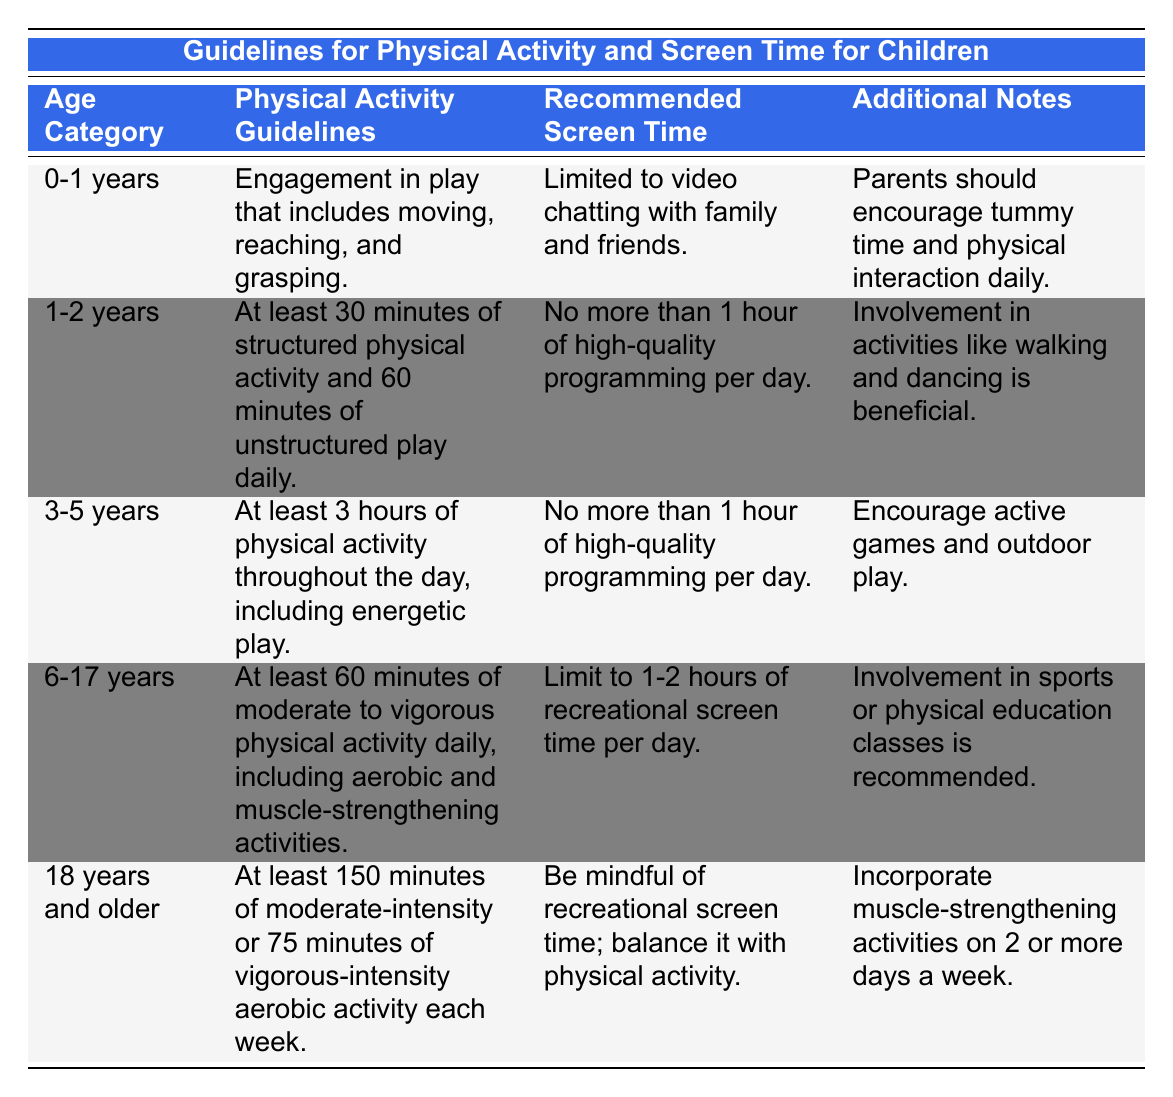What are the physical activity guidelines for 3-5 years age category? According to the table, for the age category 3-5 years, the physical activity guideline is to engage in at least 3 hours of physical activity throughout the day, including energetic play.
Answer: At least 3 hours of physical activity What is the recommended screen time for children aged 1-2 years? The table indicates that for children aged 1-2 years, the recommended screen time is no more than 1 hour of high-quality programming per day.
Answer: No more than 1 hour Is it suggested that children aged 6-17 years participate in sports? The table states that involvement in sports or physical education classes is recommended for children aged 6-17 years, indicating yes to this suggestion.
Answer: Yes How does the screen time recommendation change as children age from 3-5 years to 6-17 years? For children aged 3-5 years, the recommended screen time is no more than 1 hour of high-quality programming per day. For children aged 6-17 years, the recommendation is to limit screen time to 1-2 hours of recreational screen time per day. As they grow older, the recommendation allows slightly more screen time.
Answer: Increases from 1 hour to 1-2 hours What is the total amount of physical activity recommended for children aged 0-1 years and 1-2 years combined? The combined total for children aged 0-1 years is engagement in play and for 1-2 years it's at least 30 minutes of structured activity and 60 minutes of unstructured play. This amounts to at least 90 minutes when adding them together (30 minutes structured + 60 minutes unstructured).
Answer: At least 90 minutes Do parents of children aged 0-1 years need to limit screen time for video chatting? Yes, the table indicates that for children aged 0-1 years, screen time is limited to video chatting with family and friends, meaning it is generally restricted for other forms of screen use.
Answer: Yes What is the additional note for the 18 years and older age group about physical activity? For the age group of 18 years and older, the additional note indicates that they should incorporate muscle-strengthening activities on 2 or more days a week along with their recommended aerobic activity.
Answer: Incorporate muscle-strengthening activities 2 or more days a week 